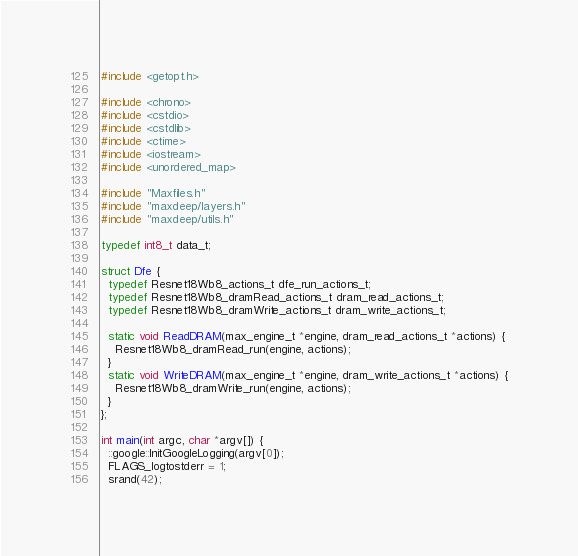Convert code to text. <code><loc_0><loc_0><loc_500><loc_500><_C++_>#include <getopt.h>

#include <chrono>
#include <cstdio>
#include <cstdlib>
#include <ctime>
#include <iostream>
#include <unordered_map>

#include "Maxfiles.h"
#include "maxdeep/layers.h"
#include "maxdeep/utils.h"

typedef int8_t data_t;

struct Dfe {
  typedef Resnet18Wb8_actions_t dfe_run_actions_t;
  typedef Resnet18Wb8_dramRead_actions_t dram_read_actions_t;
  typedef Resnet18Wb8_dramWrite_actions_t dram_write_actions_t;

  static void ReadDRAM(max_engine_t *engine, dram_read_actions_t *actions) {
    Resnet18Wb8_dramRead_run(engine, actions);
  }
  static void WriteDRAM(max_engine_t *engine, dram_write_actions_t *actions) {
    Resnet18Wb8_dramWrite_run(engine, actions);
  }
};

int main(int argc, char *argv[]) {
  ::google::InitGoogleLogging(argv[0]);
  FLAGS_logtostderr = 1;
  srand(42);
</code> 